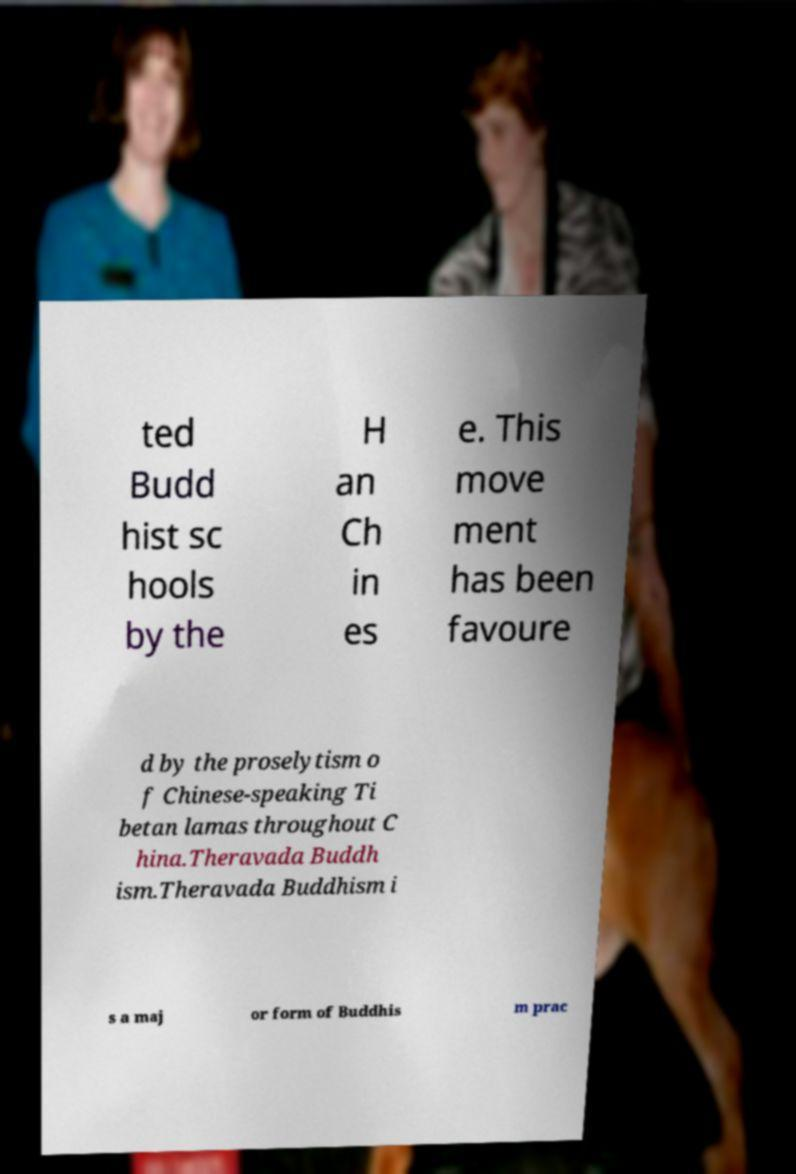There's text embedded in this image that I need extracted. Can you transcribe it verbatim? ted Budd hist sc hools by the H an Ch in es e. This move ment has been favoure d by the proselytism o f Chinese-speaking Ti betan lamas throughout C hina.Theravada Buddh ism.Theravada Buddhism i s a maj or form of Buddhis m prac 